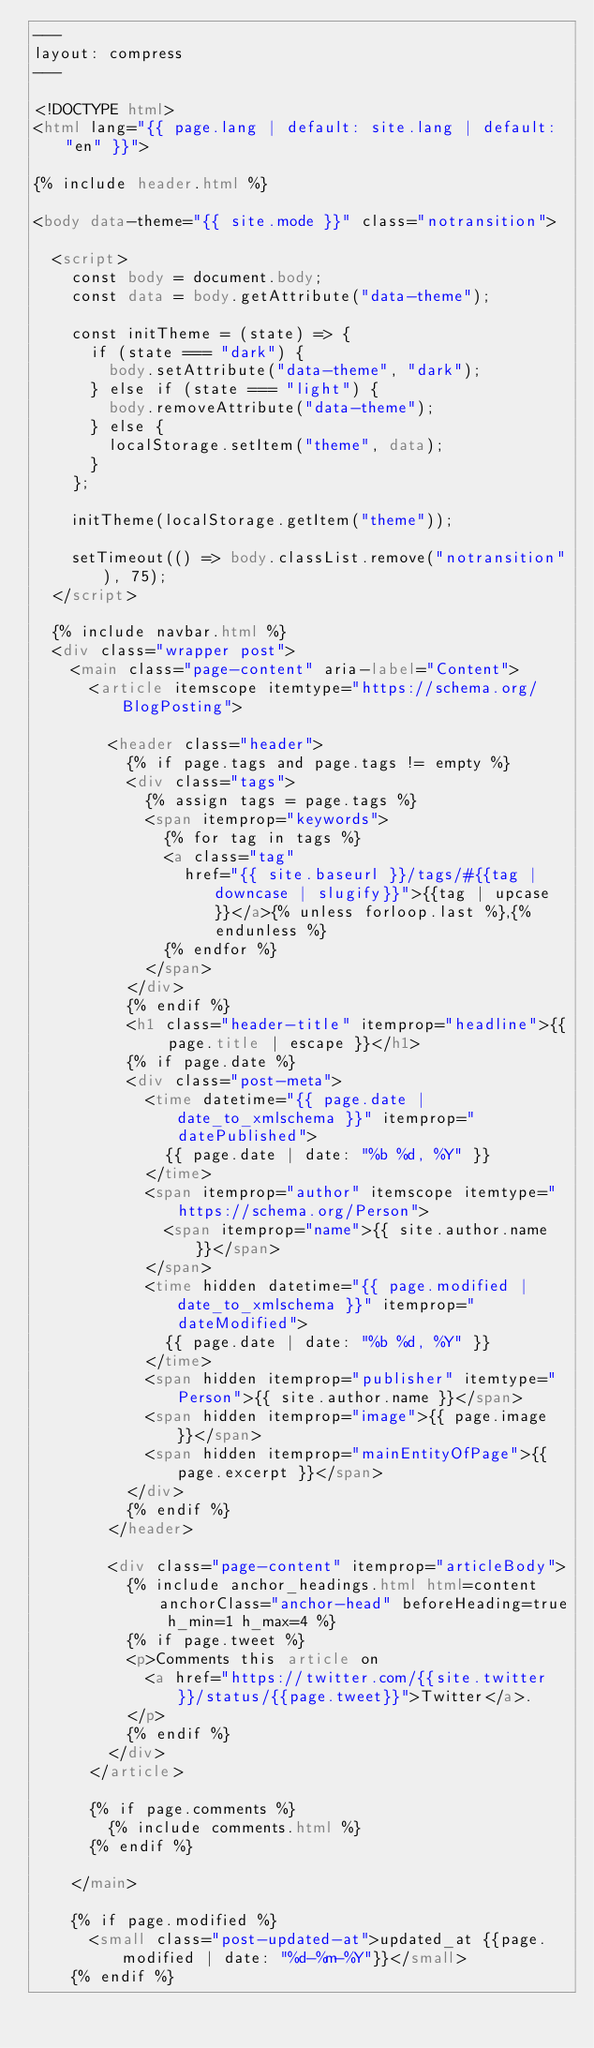Convert code to text. <code><loc_0><loc_0><loc_500><loc_500><_HTML_>---
layout: compress
---

<!DOCTYPE html>
<html lang="{{ page.lang | default: site.lang | default: "en" }}">

{% include header.html %}

<body data-theme="{{ site.mode }}" class="notransition">

  <script>
    const body = document.body;
    const data = body.getAttribute("data-theme");

    const initTheme = (state) => {
      if (state === "dark") {
        body.setAttribute("data-theme", "dark");
      } else if (state === "light") {
        body.removeAttribute("data-theme");
      } else {
        localStorage.setItem("theme", data);
      }
    };
 
    initTheme(localStorage.getItem("theme"));
    
    setTimeout(() => body.classList.remove("notransition"), 75);
  </script>

  {% include navbar.html %}
  <div class="wrapper post">
    <main class="page-content" aria-label="Content">
      <article itemscope itemtype="https://schema.org/BlogPosting">

        <header class="header">
          {% if page.tags and page.tags != empty %}
          <div class="tags">
            {% assign tags = page.tags %}
            <span itemprop="keywords">
              {% for tag in tags %}
              <a class="tag"
                href="{{ site.baseurl }}/tags/#{{tag | downcase | slugify}}">{{tag | upcase }}</a>{% unless forloop.last %},{% endunless %}
              {% endfor %}
            </span>
          </div>
          {% endif %}
          <h1 class="header-title" itemprop="headline">{{ page.title | escape }}</h1>
          {% if page.date %}
          <div class="post-meta">
            <time datetime="{{ page.date | date_to_xmlschema }}" itemprop="datePublished">
              {{ page.date | date: "%b %d, %Y" }}
            </time>
            <span itemprop="author" itemscope itemtype="https://schema.org/Person">
              <span itemprop="name">{{ site.author.name }}</span>
            </span>
            <time hidden datetime="{{ page.modified | date_to_xmlschema }}" itemprop="dateModified">
              {{ page.date | date: "%b %d, %Y" }}
            </time>
            <span hidden itemprop="publisher" itemtype="Person">{{ site.author.name }}</span>
            <span hidden itemprop="image">{{ page.image }}</span>
            <span hidden itemprop="mainEntityOfPage">{{ page.excerpt }}</span>
          </div>
          {% endif %}
        </header>

        <div class="page-content" itemprop="articleBody">
          {% include anchor_headings.html html=content anchorClass="anchor-head" beforeHeading=true h_min=1 h_max=4 %}
          {% if page.tweet %}
          <p>Comments this article on 
            <a href="https://twitter.com/{{site.twitter}}/status/{{page.tweet}}">Twitter</a>.
          </p>
          {% endif %}
        </div>
      </article>
    
      {% if page.comments %}
        {% include comments.html %}
      {% endif %}

    </main>

    {% if page.modified %}
      <small class="post-updated-at">updated_at {{page.modified | date: "%d-%m-%Y"}}</small>
    {% endif %}</code> 